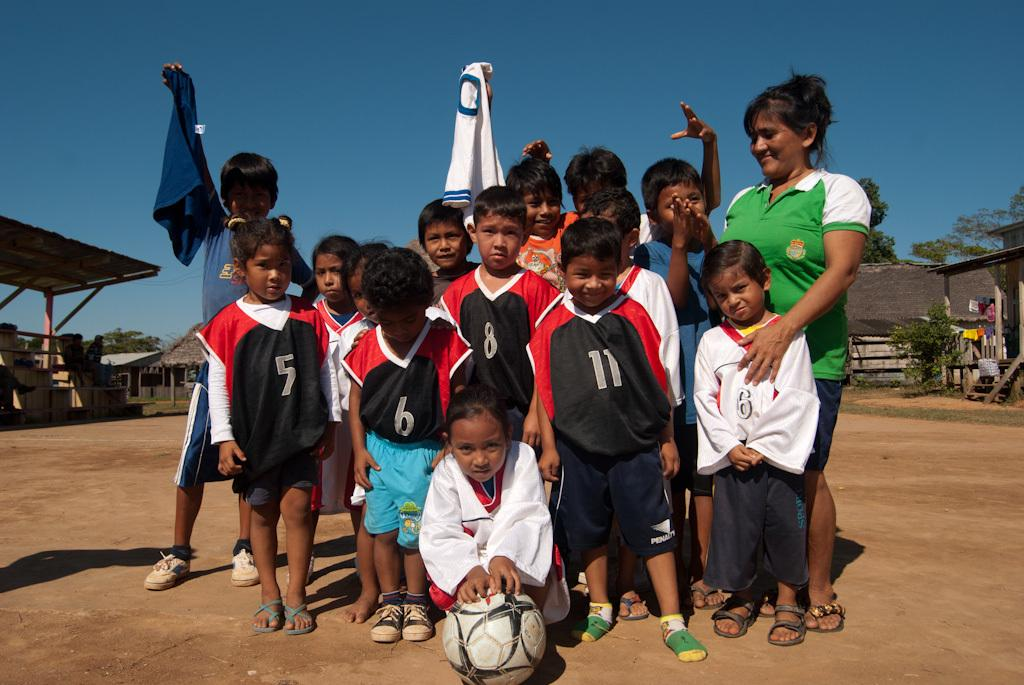What is happening in the center of the image? There are people standing in the center of the image. What is located at the bottom of the image? There is a wall at the bottom of the image. What can be seen in the background of the image? There are sheds, trees, and the sky visible in the background of the image. How many cakes are being shown in the image? There are no cakes present in the image. What type of family gathering is depicted in the image? The image does not depict a family gathering; it only shows people standing and a wall, sheds, trees, and the sky in the background. 